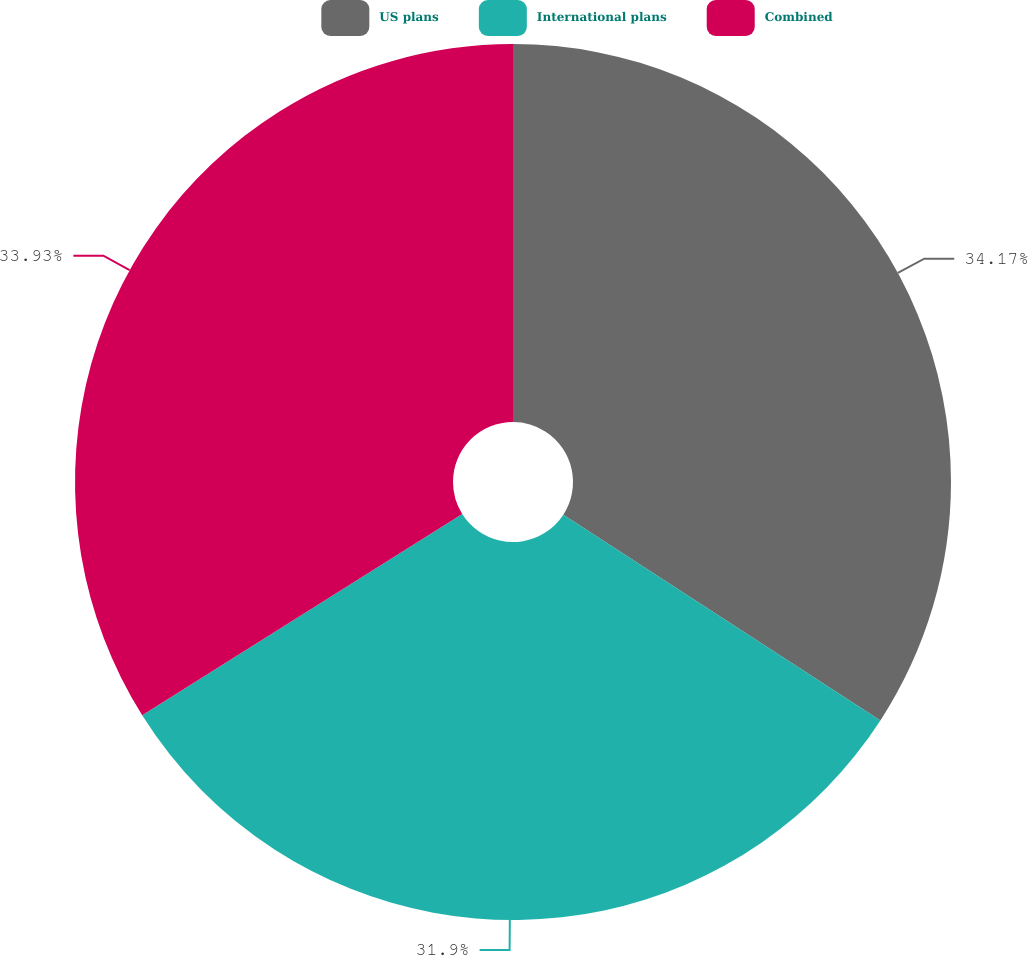Convert chart. <chart><loc_0><loc_0><loc_500><loc_500><pie_chart><fcel>US plans<fcel>International plans<fcel>Combined<nl><fcel>34.16%<fcel>31.9%<fcel>33.93%<nl></chart> 